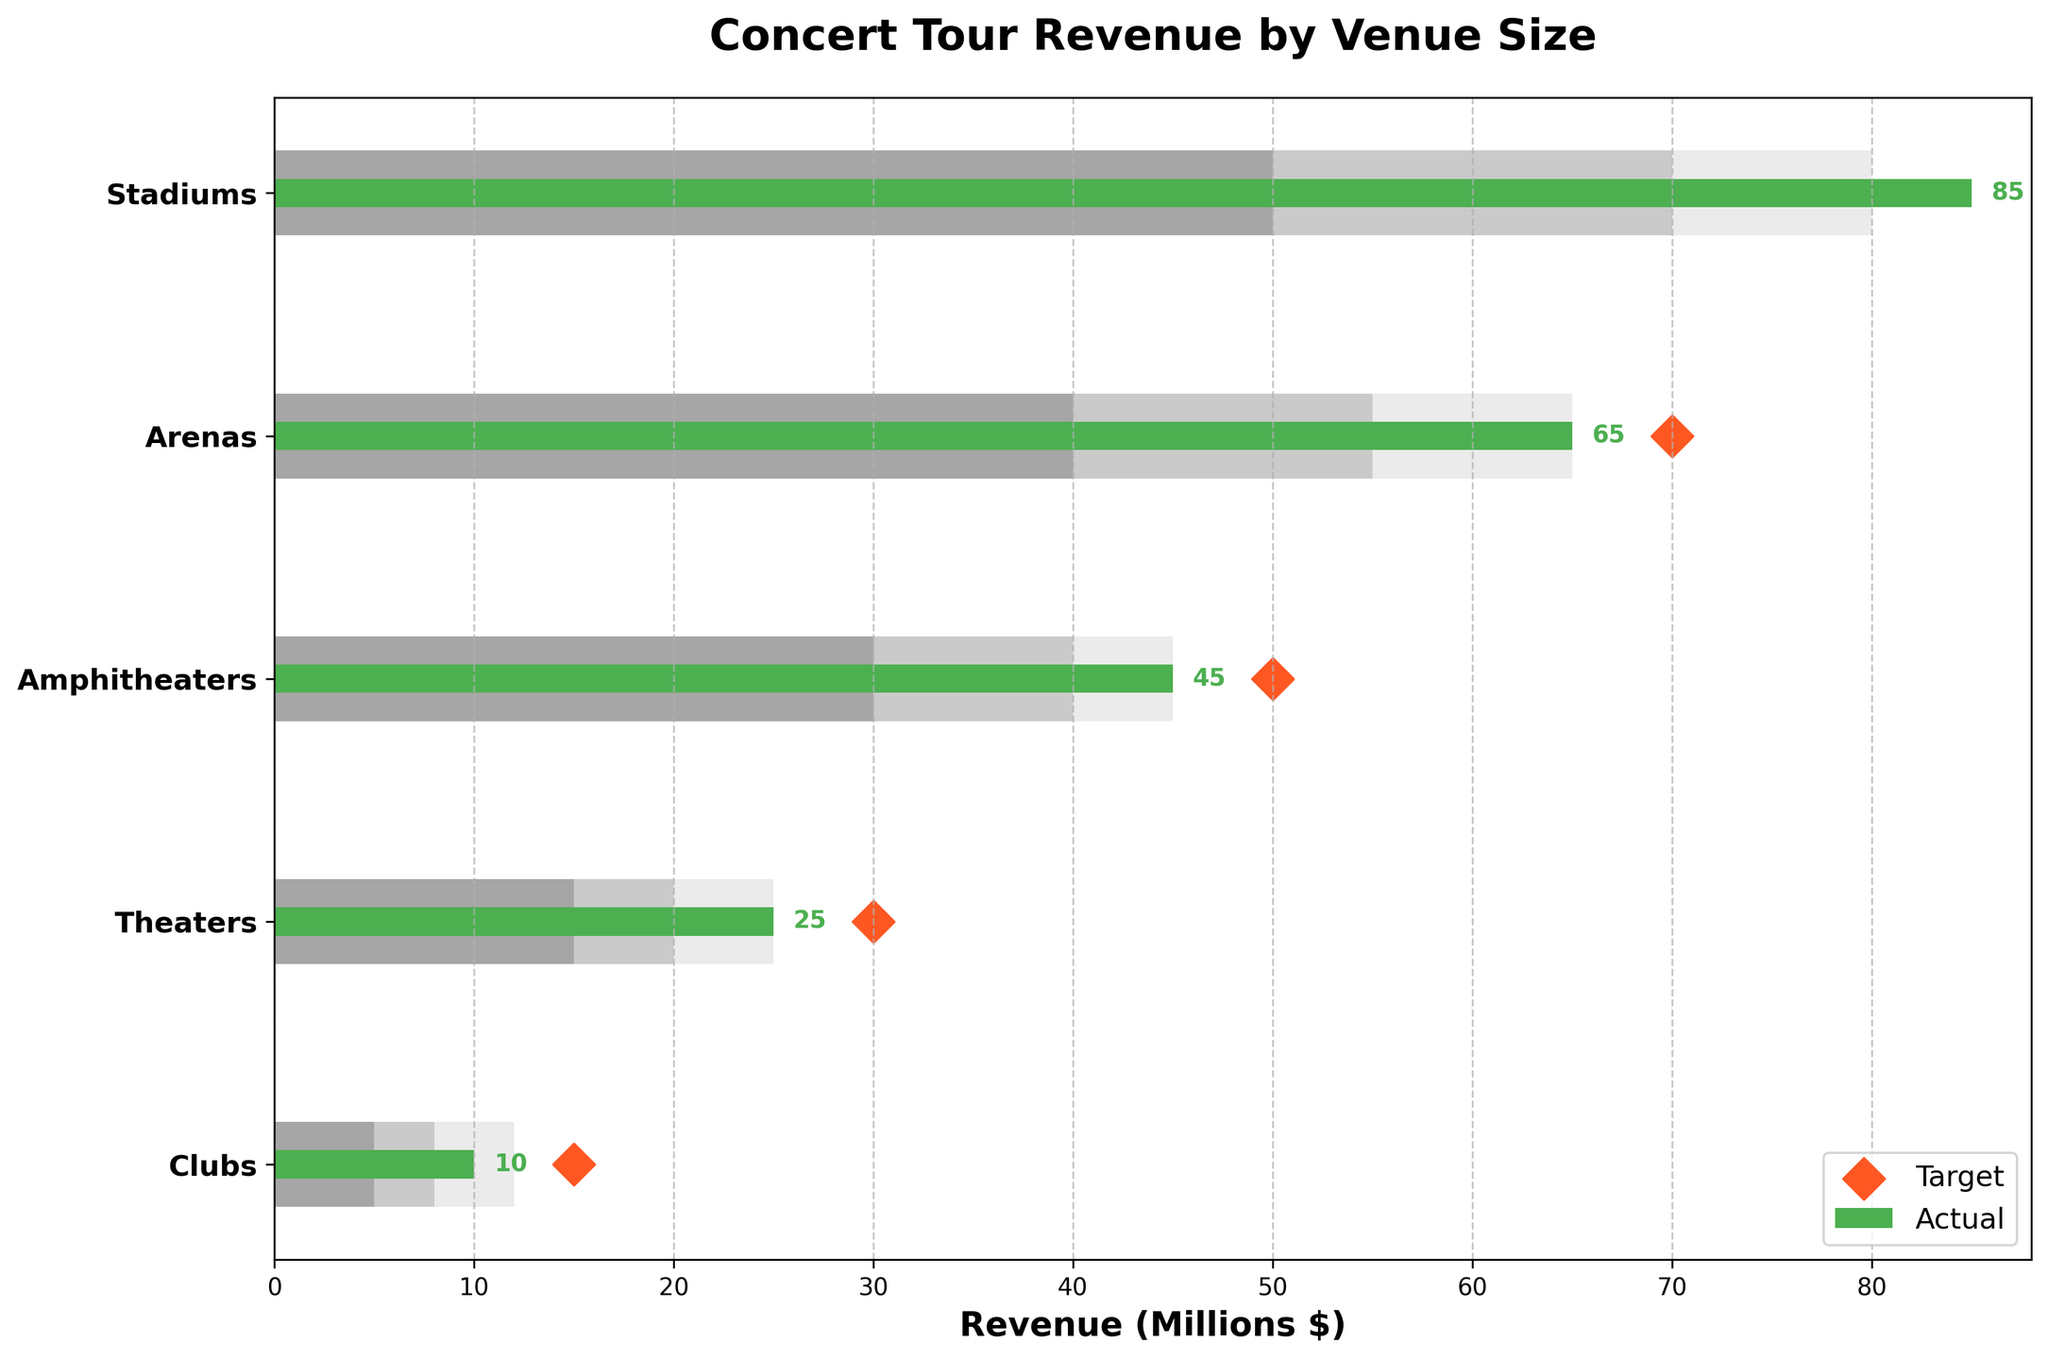What is the title of the figure? The title of the figure is typically displayed at the top of the chart. In this case, it is "Concert Tour Revenue by Venue Size" as per the provided data and code.
Answer: Concert Tour Revenue by Venue Size Which venue achieved the highest actual revenue? Among the venues, the one with the highest actual revenue is indicated by the largest green bar (Actual values). According to the data, "Stadiums" have an actual revenue of 85 million dollars, which is the highest.
Answer: Stadiums What is the difference between the actual revenue and target revenue for Arenas? The actual revenue for Arenas is 65 million dollars and the target revenue is 70 million dollars. The difference is calculated by subtracting the actual from the target: 70 - 65 = 5 million dollars.
Answer: 5 million dollars How many venues met or exceeded their range 2 targets? Range 2 is the middle segment of the gray bars (between Range 1 and Range 3). If the actual value falls within or exceeds the limits of Range 2, it is counted. According to the data, Stadiums (85), Arenas (65), and Amphitheaters (45) have actual revenues that fall within or exceed their Range 2 targets (80, 65, and 45 respectively).
Answer: 3 venues Which venue has the smallest gap between actual and target revenues and what is that gap? To find the smallest gap, calculate the differences between the actual and target revenues for each venue. The differences are: Stadiums (5), Arenas (5), Amphitheaters (5), Theaters (5), and Clubs (5). Since all gaps are the same, any venue can be chosen as the answer.
Answer: 5 million dollars What is the average actual revenue across all venue sizes? Sum the actual revenues for all venues: 85 (Stadiums) + 65 (Arenas) + 45 (Amphitheaters) + 25 (Theaters) + 10 (Clubs) = 230 million dollars. Then, divide by the number of venues (5): 230 / 5 = 46 million dollars.
Answer: 46 million dollars Which venues did not meet their target revenue? This can be determined by comparing the actual revenue to the target revenue for each venue. If the actual revenue is less than the target revenue, the venue did not meet its target. According to the data, all venues (Stadiums, Arenas, Amphitheaters, Theaters, and Clubs) did not meet their respective targets.
Answer: All venues How much higher is the actual revenue for Stadiums compared to Theaters? Subtract the actual revenue of Theaters from that of Stadiums: 85 (Stadiums) - 25 (Theaters) = 60 million dollars.
Answer: 60 million dollars 